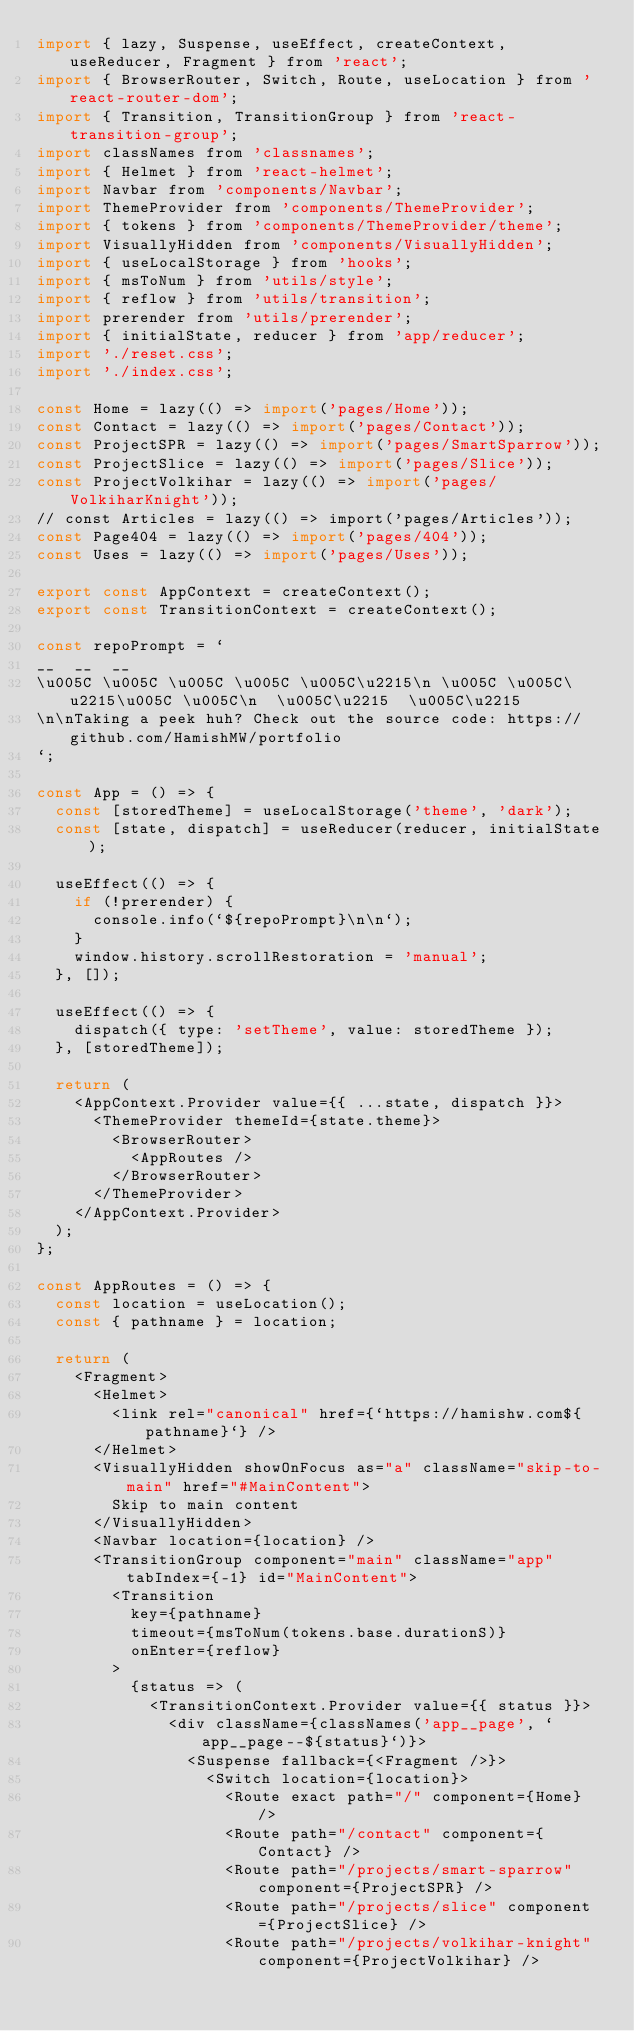<code> <loc_0><loc_0><loc_500><loc_500><_JavaScript_>import { lazy, Suspense, useEffect, createContext, useReducer, Fragment } from 'react';
import { BrowserRouter, Switch, Route, useLocation } from 'react-router-dom';
import { Transition, TransitionGroup } from 'react-transition-group';
import classNames from 'classnames';
import { Helmet } from 'react-helmet';
import Navbar from 'components/Navbar';
import ThemeProvider from 'components/ThemeProvider';
import { tokens } from 'components/ThemeProvider/theme';
import VisuallyHidden from 'components/VisuallyHidden';
import { useLocalStorage } from 'hooks';
import { msToNum } from 'utils/style';
import { reflow } from 'utils/transition';
import prerender from 'utils/prerender';
import { initialState, reducer } from 'app/reducer';
import './reset.css';
import './index.css';

const Home = lazy(() => import('pages/Home'));
const Contact = lazy(() => import('pages/Contact'));
const ProjectSPR = lazy(() => import('pages/SmartSparrow'));
const ProjectSlice = lazy(() => import('pages/Slice'));
const ProjectVolkihar = lazy(() => import('pages/VolkiharKnight'));
// const Articles = lazy(() => import('pages/Articles'));
const Page404 = lazy(() => import('pages/404'));
const Uses = lazy(() => import('pages/Uses'));

export const AppContext = createContext();
export const TransitionContext = createContext();

const repoPrompt = `
__  __  __
\u005C \u005C \u005C \u005C \u005C\u2215\n \u005C \u005C\u2215\u005C \u005C\n  \u005C\u2215  \u005C\u2215
\n\nTaking a peek huh? Check out the source code: https://github.com/HamishMW/portfolio
`;

const App = () => {
  const [storedTheme] = useLocalStorage('theme', 'dark');
  const [state, dispatch] = useReducer(reducer, initialState);

  useEffect(() => {
    if (!prerender) {
      console.info(`${repoPrompt}\n\n`);
    }
    window.history.scrollRestoration = 'manual';
  }, []);

  useEffect(() => {
    dispatch({ type: 'setTheme', value: storedTheme });
  }, [storedTheme]);

  return (
    <AppContext.Provider value={{ ...state, dispatch }}>
      <ThemeProvider themeId={state.theme}>
        <BrowserRouter>
          <AppRoutes />
        </BrowserRouter>
      </ThemeProvider>
    </AppContext.Provider>
  );
};

const AppRoutes = () => {
  const location = useLocation();
  const { pathname } = location;

  return (
    <Fragment>
      <Helmet>
        <link rel="canonical" href={`https://hamishw.com${pathname}`} />
      </Helmet>
      <VisuallyHidden showOnFocus as="a" className="skip-to-main" href="#MainContent">
        Skip to main content
      </VisuallyHidden>
      <Navbar location={location} />
      <TransitionGroup component="main" className="app" tabIndex={-1} id="MainContent">
        <Transition
          key={pathname}
          timeout={msToNum(tokens.base.durationS)}
          onEnter={reflow}
        >
          {status => (
            <TransitionContext.Provider value={{ status }}>
              <div className={classNames('app__page', `app__page--${status}`)}>
                <Suspense fallback={<Fragment />}>
                  <Switch location={location}>
                    <Route exact path="/" component={Home} />
                    <Route path="/contact" component={Contact} />
                    <Route path="/projects/smart-sparrow" component={ProjectSPR} />
                    <Route path="/projects/slice" component={ProjectSlice} />
                    <Route path="/projects/volkihar-knight" component={ProjectVolkihar} /></code> 